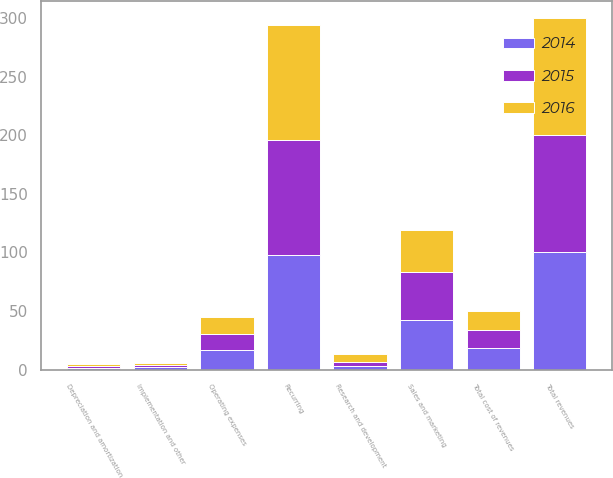<chart> <loc_0><loc_0><loc_500><loc_500><stacked_bar_chart><ecel><fcel>Recurring<fcel>Implementation and other<fcel>Total revenues<fcel>Operating expenses<fcel>Depreciation and amortization<fcel>Total cost of revenues<fcel>Sales and marketing<fcel>Research and development<nl><fcel>2016<fcel>98.3<fcel>1.7<fcel>100<fcel>14.6<fcel>1.8<fcel>16.4<fcel>36.2<fcel>6.4<nl><fcel>2015<fcel>97.9<fcel>2.1<fcel>100<fcel>14.2<fcel>1.6<fcel>15.8<fcel>41.2<fcel>3.8<nl><fcel>2014<fcel>98.2<fcel>1.8<fcel>100<fcel>16.4<fcel>1.7<fcel>18.1<fcel>42.1<fcel>2.9<nl></chart> 